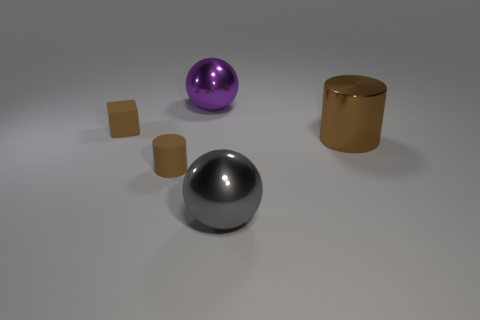There is a brown thing that is right of the tiny matte block and behind the brown matte cylinder; what shape is it?
Make the answer very short. Cylinder. What number of cubes have the same size as the gray ball?
Provide a succinct answer. 0. There is a brown thing to the right of the big ball to the left of the gray ball; what is its shape?
Provide a short and direct response. Cylinder. The brown thing on the right side of the sphere left of the metallic thing that is in front of the brown metallic cylinder is what shape?
Make the answer very short. Cylinder. What number of brown objects are the same shape as the gray object?
Give a very brief answer. 0. How many big brown cylinders are right of the big cylinder that is behind the big gray metallic sphere?
Make the answer very short. 0. What number of rubber objects are large brown cylinders or large yellow blocks?
Keep it short and to the point. 0. Are there any big things that have the same material as the brown block?
Offer a very short reply. No. How many objects are big metal balls in front of the small brown block or large spheres on the right side of the big purple metallic thing?
Your answer should be compact. 1. There is a small thing in front of the small cube; is it the same color as the small cube?
Make the answer very short. Yes. 